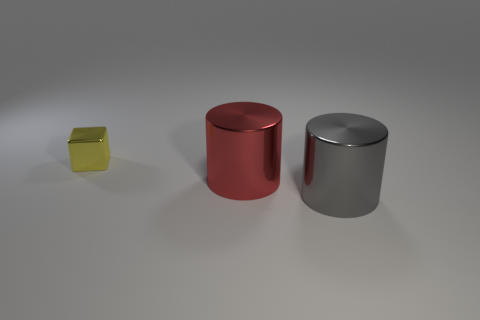Add 1 large brown metal balls. How many objects exist? 4 Subtract all blocks. How many objects are left? 2 Add 1 large cyan rubber blocks. How many large cyan rubber blocks exist? 1 Subtract 0 blue balls. How many objects are left? 3 Subtract all green cubes. Subtract all tiny metallic blocks. How many objects are left? 2 Add 3 yellow metal things. How many yellow metal things are left? 4 